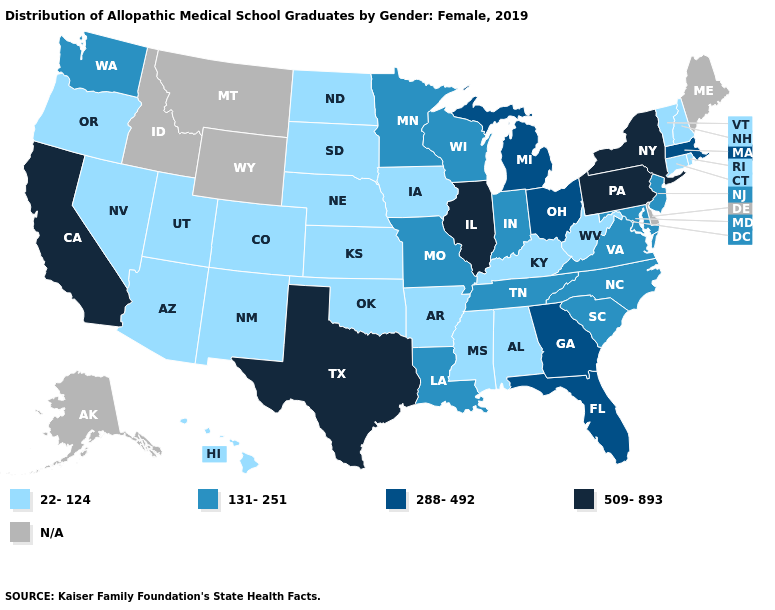What is the value of Alaska?
Concise answer only. N/A. What is the value of Ohio?
Keep it brief. 288-492. What is the value of New York?
Write a very short answer. 509-893. What is the lowest value in the USA?
Quick response, please. 22-124. Name the states that have a value in the range 131-251?
Be succinct. Indiana, Louisiana, Maryland, Minnesota, Missouri, New Jersey, North Carolina, South Carolina, Tennessee, Virginia, Washington, Wisconsin. Does Texas have the highest value in the South?
Quick response, please. Yes. Does Arizona have the lowest value in the West?
Write a very short answer. Yes. Which states have the lowest value in the USA?
Write a very short answer. Alabama, Arizona, Arkansas, Colorado, Connecticut, Hawaii, Iowa, Kansas, Kentucky, Mississippi, Nebraska, Nevada, New Hampshire, New Mexico, North Dakota, Oklahoma, Oregon, Rhode Island, South Dakota, Utah, Vermont, West Virginia. Among the states that border Maryland , does West Virginia have the highest value?
Short answer required. No. What is the lowest value in the USA?
Write a very short answer. 22-124. Among the states that border Nebraska , does Iowa have the highest value?
Write a very short answer. No. Does Alabama have the lowest value in the South?
Keep it brief. Yes. Which states have the lowest value in the USA?
Concise answer only. Alabama, Arizona, Arkansas, Colorado, Connecticut, Hawaii, Iowa, Kansas, Kentucky, Mississippi, Nebraska, Nevada, New Hampshire, New Mexico, North Dakota, Oklahoma, Oregon, Rhode Island, South Dakota, Utah, Vermont, West Virginia. Name the states that have a value in the range N/A?
Give a very brief answer. Alaska, Delaware, Idaho, Maine, Montana, Wyoming. Among the states that border Arkansas , does Oklahoma have the lowest value?
Give a very brief answer. Yes. 